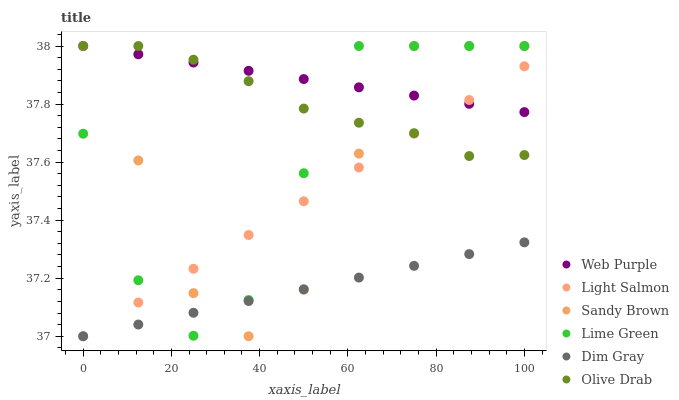Does Dim Gray have the minimum area under the curve?
Answer yes or no. Yes. Does Web Purple have the maximum area under the curve?
Answer yes or no. Yes. Does Sandy Brown have the minimum area under the curve?
Answer yes or no. No. Does Sandy Brown have the maximum area under the curve?
Answer yes or no. No. Is Light Salmon the smoothest?
Answer yes or no. Yes. Is Sandy Brown the roughest?
Answer yes or no. Yes. Is Dim Gray the smoothest?
Answer yes or no. No. Is Dim Gray the roughest?
Answer yes or no. No. Does Light Salmon have the lowest value?
Answer yes or no. Yes. Does Sandy Brown have the lowest value?
Answer yes or no. No. Does Olive Drab have the highest value?
Answer yes or no. Yes. Does Dim Gray have the highest value?
Answer yes or no. No. Is Dim Gray less than Olive Drab?
Answer yes or no. Yes. Is Web Purple greater than Dim Gray?
Answer yes or no. Yes. Does Light Salmon intersect Olive Drab?
Answer yes or no. Yes. Is Light Salmon less than Olive Drab?
Answer yes or no. No. Is Light Salmon greater than Olive Drab?
Answer yes or no. No. Does Dim Gray intersect Olive Drab?
Answer yes or no. No. 